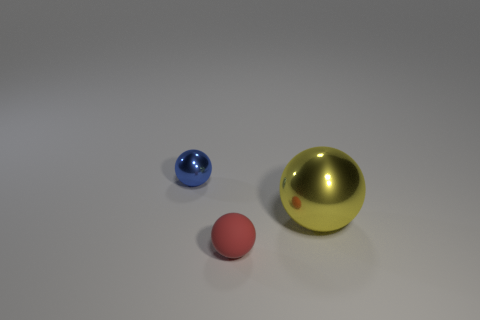Does the object behind the big yellow shiny object have the same shape as the red object?
Your response must be concise. Yes. The small object that is on the right side of the small sphere that is behind the red ball is what color?
Give a very brief answer. Red. Are there fewer matte objects than tiny things?
Ensure brevity in your answer.  Yes. Is there a tiny object that has the same material as the large yellow object?
Offer a very short reply. Yes. There is a small red object; is it the same shape as the thing that is right of the red rubber object?
Keep it short and to the point. Yes. Are there any red matte spheres to the left of the big metallic sphere?
Ensure brevity in your answer.  Yes. What number of small metal objects have the same shape as the small red rubber thing?
Provide a short and direct response. 1. Are the tiny blue thing and the thing that is on the right side of the red matte thing made of the same material?
Keep it short and to the point. Yes. How many blue shiny things are there?
Ensure brevity in your answer.  1. There is a thing on the left side of the tiny red ball; how big is it?
Offer a very short reply. Small. 